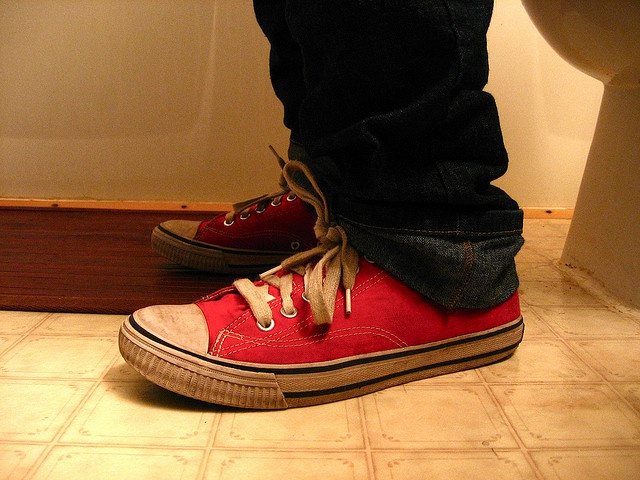Describe the objects in this image and their specific colors. I can see people in olive, black, brown, and maroon tones and toilet in olive, maroon, and brown tones in this image. 